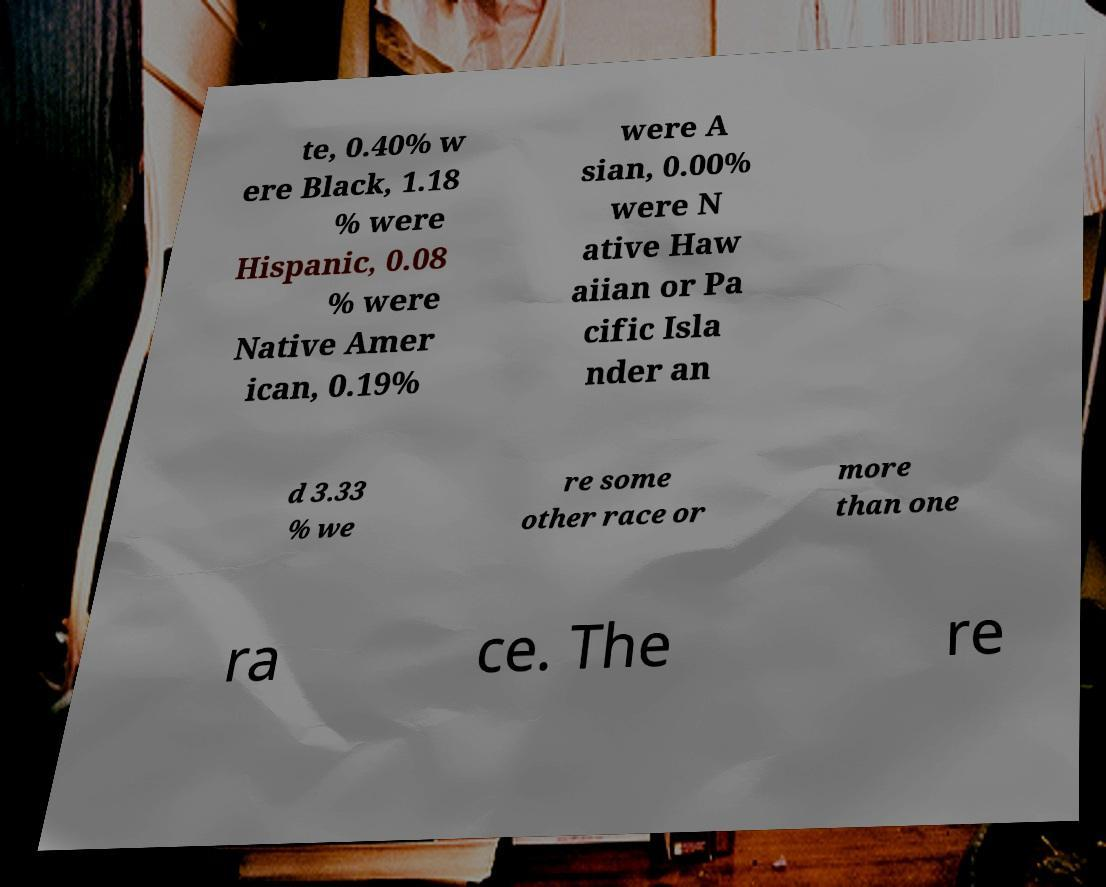Could you extract and type out the text from this image? te, 0.40% w ere Black, 1.18 % were Hispanic, 0.08 % were Native Amer ican, 0.19% were A sian, 0.00% were N ative Haw aiian or Pa cific Isla nder an d 3.33 % we re some other race or more than one ra ce. The re 